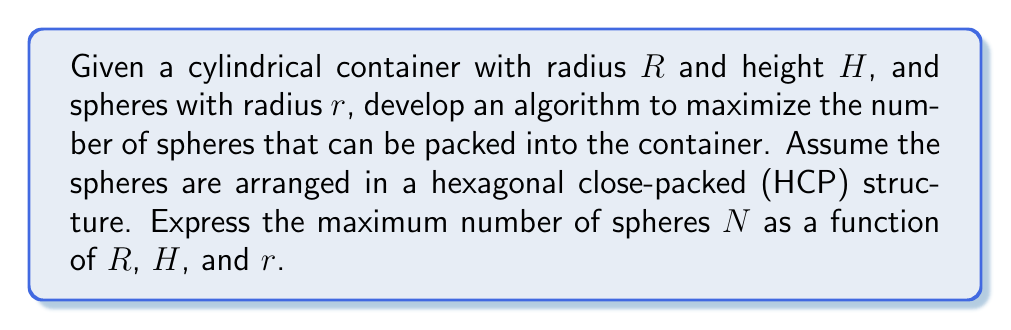Help me with this question. To solve this problem, we'll follow these steps:

1. Determine the number of layers of spheres that can fit in the cylinder's height.
2. Calculate the number of spheres in each layer.
3. Combine the results to get the total number of spheres.

Step 1: Number of layers

In an HCP structure, the height of each layer is $\sqrt{\frac{8}{3}}r$. The number of layers $n_l$ is:

$$n_l = \left\lfloor\frac{H}{\sqrt{\frac{8}{3}}r}\right\rfloor$$

Where $\lfloor \cdot \rfloor$ denotes the floor function.

Step 2: Spheres per layer

In a hexagonal arrangement, the area of each hexagon containing a sphere is:

$$A_{hex} = 2\sqrt{3}r^2$$

The number of complete hexagons that fit in the circular base is approximately:

$$n_h = \left\lfloor\frac{\pi R^2}{2\sqrt{3}r^2}\right\rfloor$$

Step 3: Total number of spheres

Combining the results from steps 1 and 2, and accounting for the alternating pattern in HCP structure:

$$N = n_h \cdot n_l + \left\lfloor\frac{n_h}{2}\right\rfloor$$

Substituting the expressions for $n_l$ and $n_h$:

$$N = \left\lfloor\frac{\pi R^2}{2\sqrt{3}r^2}\right\rfloor \cdot \left\lfloor\frac{H}{\sqrt{\frac{8}{3}}r}\right\rfloor + \left\lfloor\frac{1}{2}\left\lfloor\frac{\pi R^2}{2\sqrt{3}r^2}\right\rfloor\right\rfloor$$

This formula gives an approximation of the maximum number of spheres that can be packed into the cylindrical container using an HCP structure.

To implement this in code, you would need to create a function that takes $R$, $H$, and $r$ as inputs and returns $N$ using the formula above. You may also want to consider edge cases and optimizations for specific container and sphere sizes.
Answer: The maximum number of spheres $N$ that can be packed into a cylindrical container with radius $R$ and height $H$, using spheres of radius $r$ in an HCP structure, is approximately:

$$N = \left\lfloor\frac{\pi R^2}{2\sqrt{3}r^2}\right\rfloor \cdot \left\lfloor\frac{H}{\sqrt{\frac{8}{3}}r}\right\rfloor + \left\lfloor\frac{1}{2}\left\lfloor\frac{\pi R^2}{2\sqrt{3}r^2}\right\rfloor\right\rfloor$$ 